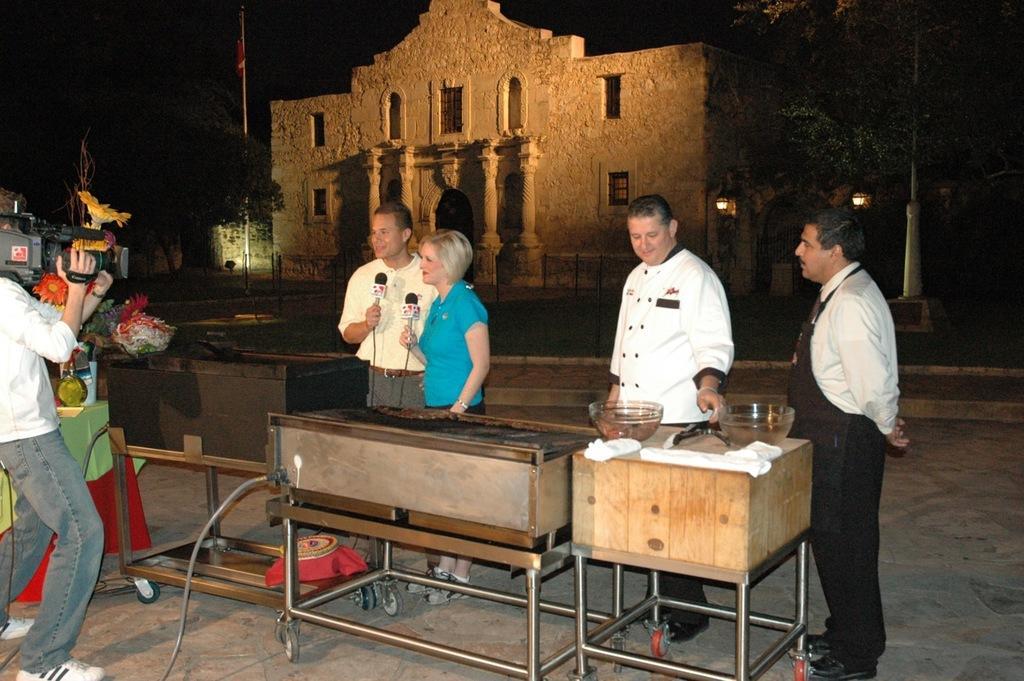Describe this image in one or two sentences. In this picture there are two people standing and holding the microphones and there are two people standing. At the back there are buildings and trees and there are street lights and there is a flag. In the foreground there is a stove and there are bowls on the table and there is a flower vase on the table. At the top there is sky. At the bottom there is a road. 